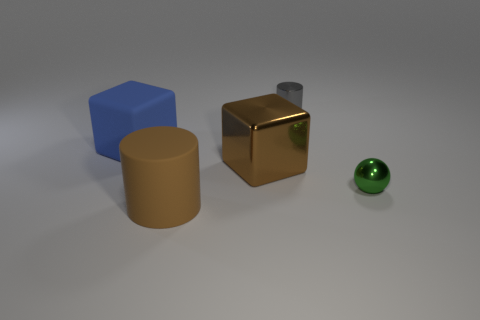Is the number of balls on the right side of the brown metal cube greater than the number of large shiny spheres?
Keep it short and to the point. Yes. Are there an equal number of things on the right side of the large matte cylinder and small green objects that are to the right of the small green object?
Offer a very short reply. No. What is the color of the thing that is both on the right side of the big metal thing and in front of the large brown metal cube?
Give a very brief answer. Green. Are there more metal cubes in front of the metallic ball than tiny gray metallic objects that are to the left of the large brown metal object?
Offer a terse response. No. There is a matte object that is in front of the rubber block; is it the same size as the large blue matte cube?
Make the answer very short. Yes. There is a big brown thing that is right of the large brown object that is in front of the sphere; what number of brown objects are in front of it?
Provide a succinct answer. 1. How big is the shiny object that is on the right side of the brown metallic object and on the left side of the small shiny sphere?
Offer a very short reply. Small. How many other things are there of the same shape as the big blue object?
Offer a very short reply. 1. There is a brown metallic thing; how many shiny things are to the right of it?
Offer a terse response. 2. Are there fewer tiny balls in front of the green ball than cylinders in front of the small cylinder?
Your answer should be compact. Yes. 